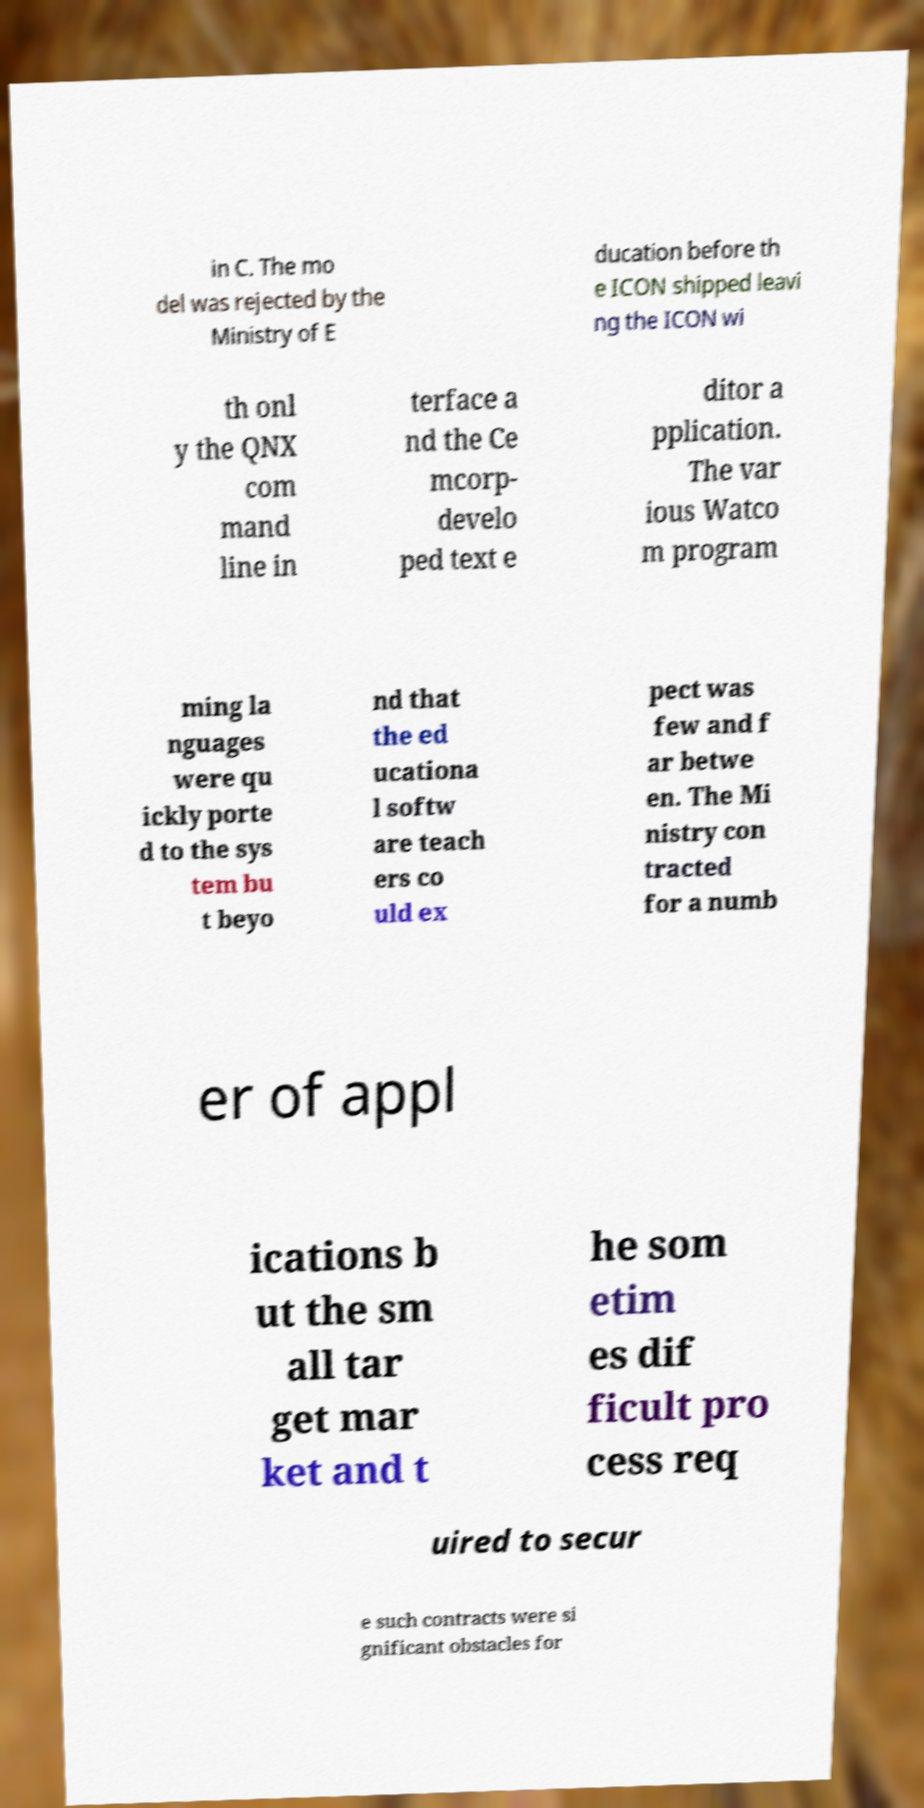Could you extract and type out the text from this image? in C. The mo del was rejected by the Ministry of E ducation before th e ICON shipped leavi ng the ICON wi th onl y the QNX com mand line in terface a nd the Ce mcorp- develo ped text e ditor a pplication. The var ious Watco m program ming la nguages were qu ickly porte d to the sys tem bu t beyo nd that the ed ucationa l softw are teach ers co uld ex pect was few and f ar betwe en. The Mi nistry con tracted for a numb er of appl ications b ut the sm all tar get mar ket and t he som etim es dif ficult pro cess req uired to secur e such contracts were si gnificant obstacles for 